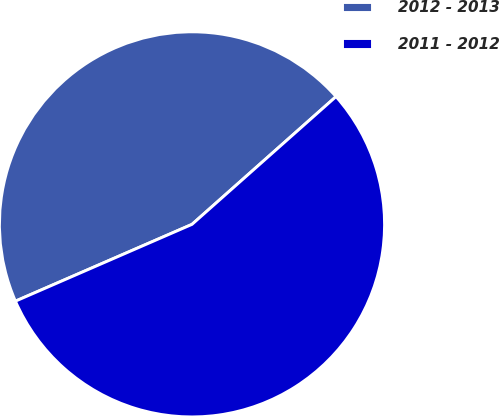<chart> <loc_0><loc_0><loc_500><loc_500><pie_chart><fcel>2012 - 2013<fcel>2011 - 2012<nl><fcel>44.98%<fcel>55.02%<nl></chart> 